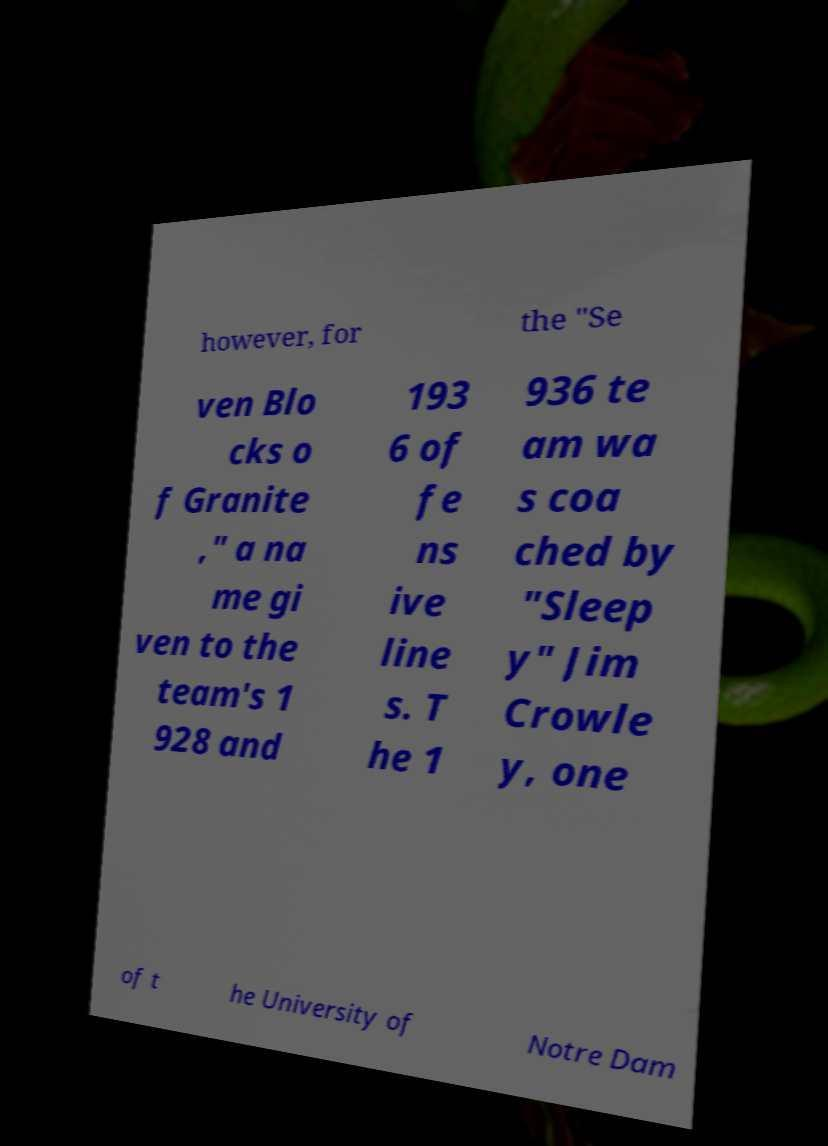Please identify and transcribe the text found in this image. however, for the "Se ven Blo cks o f Granite ," a na me gi ven to the team's 1 928 and 193 6 of fe ns ive line s. T he 1 936 te am wa s coa ched by "Sleep y" Jim Crowle y, one of t he University of Notre Dam 